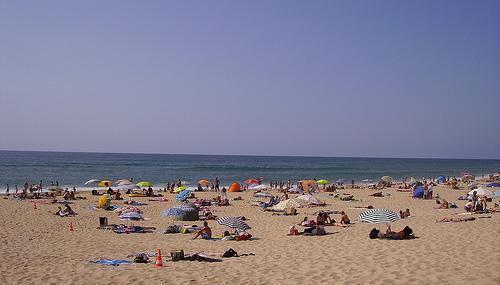How many orange and white traffic cones are on the beach?
Give a very brief answer. 3. How many black and white striped umbrellas are there?
Give a very brief answer. 2. 